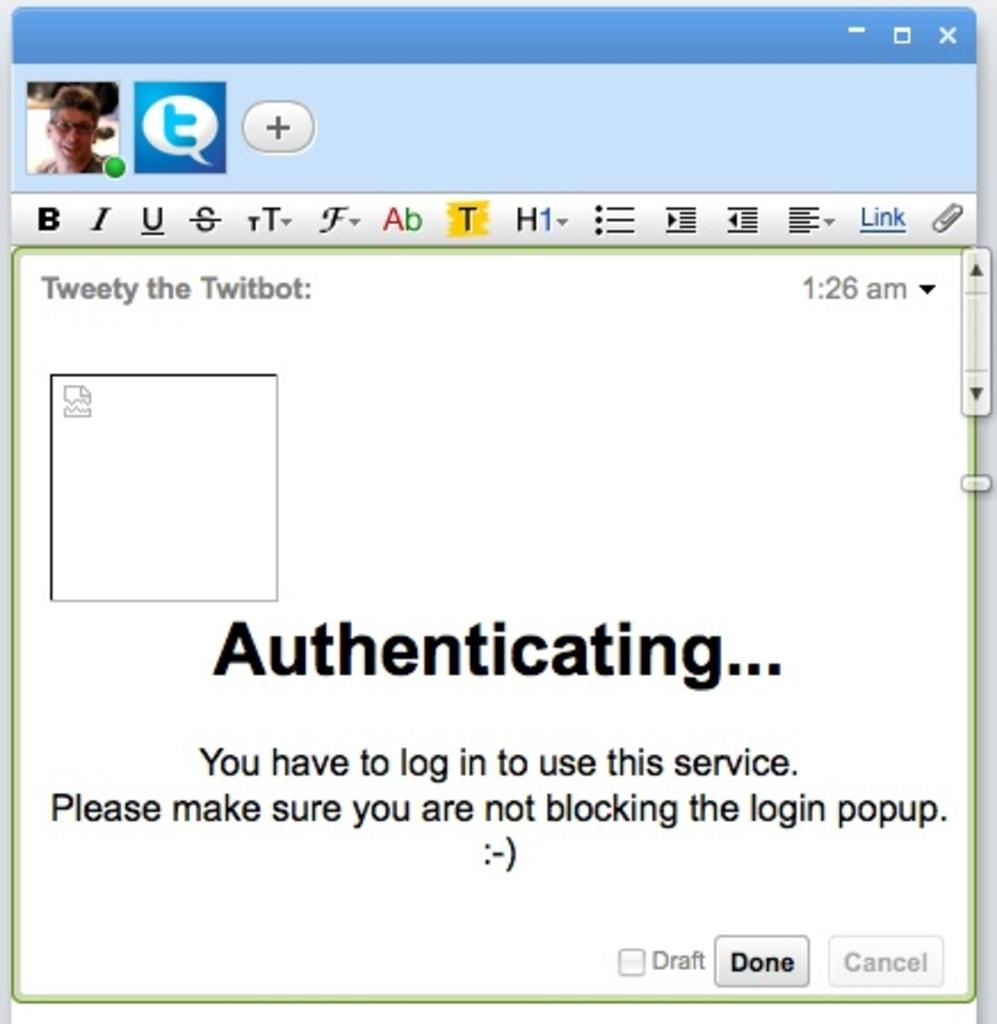What type of page is shown in the image? There is a Twitter page in the image. Is there any image or picture on the Twitter page? Yes, there is a picture of a man in the top left corner of the image. What can be found on the Twitter page besides the picture? There is text on the Twitter page. How many fowl are visible in the image? There are no fowl present in the image. Is there a window visible in the image? The image does not show a window; it is a screenshot of a Twitter page. 